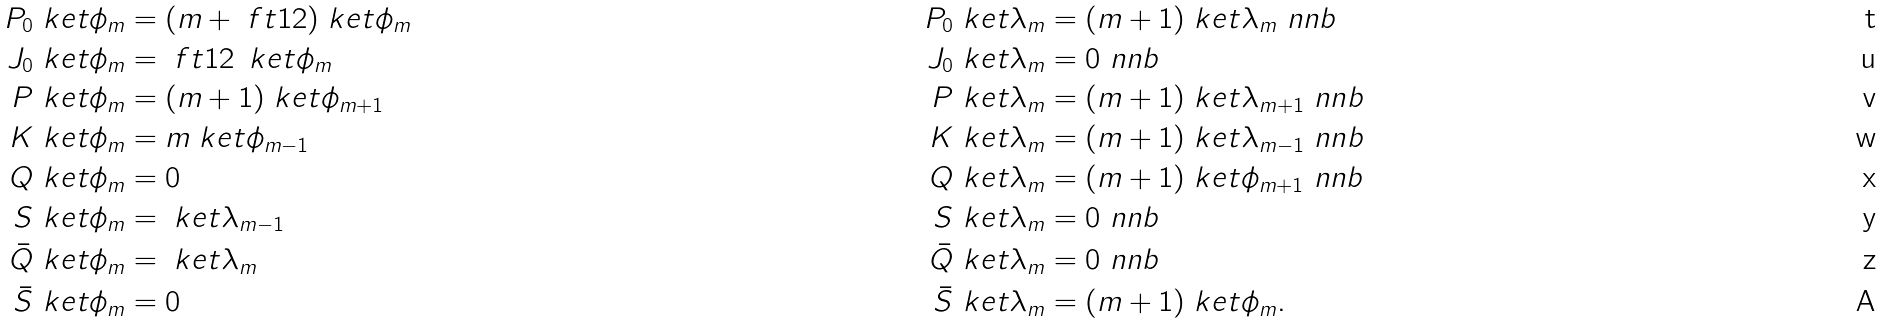Convert formula to latex. <formula><loc_0><loc_0><loc_500><loc_500>P _ { 0 } \ k e t { \phi _ { m } } & = ( m + \ f t 1 2 ) \ k e t { \phi _ { m } } & P _ { 0 } \ k e t { \lambda _ { m } } & = ( m + 1 ) \ k e t { \lambda _ { m } } \ n n b \\ J _ { 0 } \ k e t { \phi _ { m } } & = \ f t 1 2 \, \ k e t { \phi _ { m } } & J _ { 0 } \ k e t { \lambda _ { m } } & = 0 \ n n b \\ P \ k e t { \phi _ { m } } & = ( m + 1 ) \ k e t { \phi _ { m + 1 } } & P \ k e t { \lambda _ { m } } & = ( m + 1 ) \ k e t { \lambda _ { m + 1 } } \ n n b \\ K \ k e t { \phi _ { m } } & = m \ k e t { \phi _ { m - 1 } } & K \ k e t { \lambda _ { m } } & = ( m + 1 ) \ k e t { \lambda _ { m - 1 } } \ n n b \\ Q \ k e t { \phi _ { m } } & = 0 & Q \ k e t { \lambda _ { m } } & = ( m + 1 ) \ k e t { \phi _ { m + 1 } } \ n n b \\ S \ k e t { \phi _ { m } } & = \ k e t { \lambda _ { m - 1 } } & S \ k e t { \lambda _ { m } } & = 0 \ n n b \\ \bar { Q } \ k e t { \phi _ { m } } & = \ k e t { \lambda _ { m } } & \bar { Q } \ k e t { \lambda _ { m } } & = 0 \ n n b \\ \bar { S } \ k e t { \phi _ { m } } & = 0 & \bar { S } \ k e t { \lambda _ { m } } & = ( m + 1 ) \ k e t { \phi _ { m } } .</formula> 